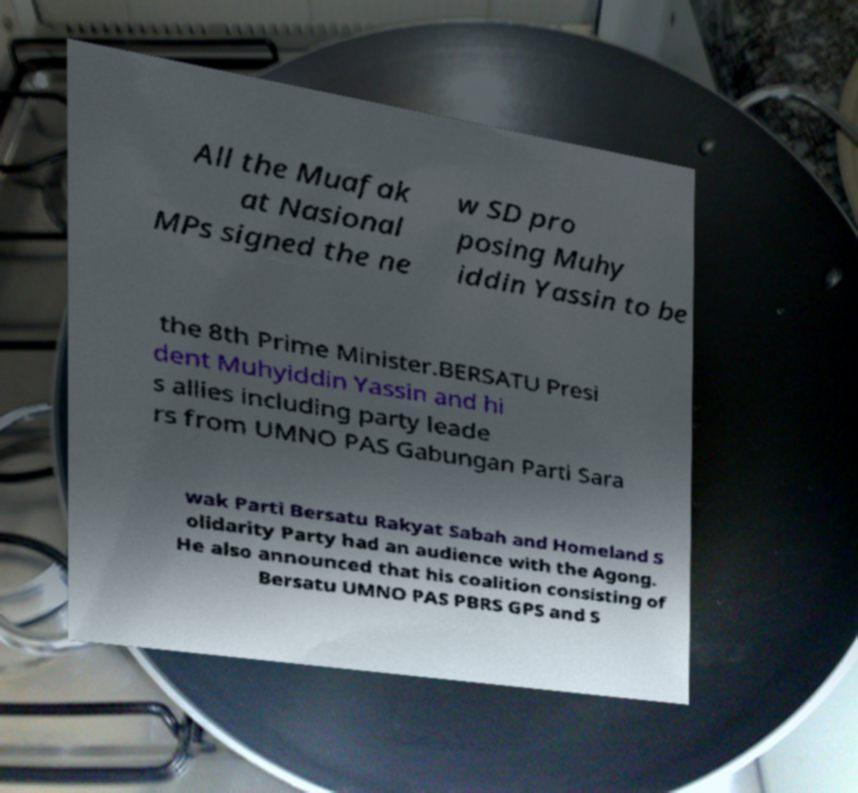There's text embedded in this image that I need extracted. Can you transcribe it verbatim? All the Muafak at Nasional MPs signed the ne w SD pro posing Muhy iddin Yassin to be the 8th Prime Minister.BERSATU Presi dent Muhyiddin Yassin and hi s allies including party leade rs from UMNO PAS Gabungan Parti Sara wak Parti Bersatu Rakyat Sabah and Homeland S olidarity Party had an audience with the Agong. He also announced that his coalition consisting of Bersatu UMNO PAS PBRS GPS and S 